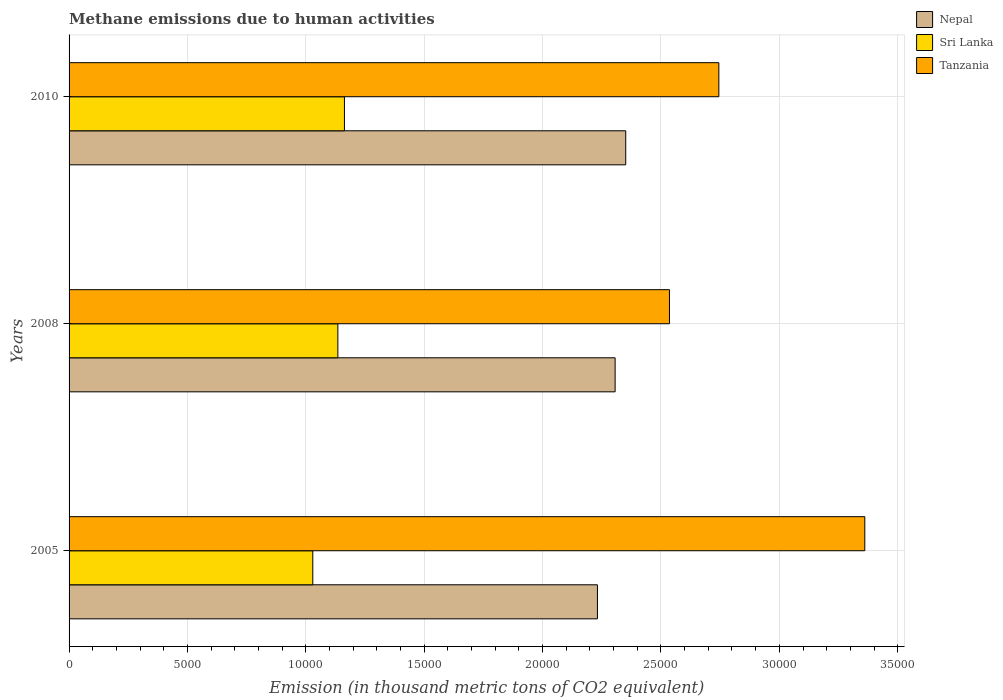How many different coloured bars are there?
Ensure brevity in your answer.  3. Are the number of bars per tick equal to the number of legend labels?
Make the answer very short. Yes. How many bars are there on the 1st tick from the top?
Offer a very short reply. 3. What is the label of the 3rd group of bars from the top?
Your response must be concise. 2005. What is the amount of methane emitted in Tanzania in 2005?
Ensure brevity in your answer.  3.36e+04. Across all years, what is the maximum amount of methane emitted in Sri Lanka?
Make the answer very short. 1.16e+04. Across all years, what is the minimum amount of methane emitted in Sri Lanka?
Make the answer very short. 1.03e+04. In which year was the amount of methane emitted in Sri Lanka maximum?
Your response must be concise. 2010. In which year was the amount of methane emitted in Nepal minimum?
Offer a terse response. 2005. What is the total amount of methane emitted in Nepal in the graph?
Offer a terse response. 6.89e+04. What is the difference between the amount of methane emitted in Sri Lanka in 2008 and that in 2010?
Your response must be concise. -277.7. What is the difference between the amount of methane emitted in Sri Lanka in 2010 and the amount of methane emitted in Nepal in 2005?
Offer a terse response. -1.07e+04. What is the average amount of methane emitted in Tanzania per year?
Provide a succinct answer. 2.88e+04. In the year 2008, what is the difference between the amount of methane emitted in Sri Lanka and amount of methane emitted in Nepal?
Offer a very short reply. -1.17e+04. In how many years, is the amount of methane emitted in Tanzania greater than 34000 thousand metric tons?
Your answer should be compact. 0. What is the ratio of the amount of methane emitted in Sri Lanka in 2005 to that in 2010?
Offer a terse response. 0.89. Is the amount of methane emitted in Nepal in 2005 less than that in 2010?
Your answer should be compact. Yes. Is the difference between the amount of methane emitted in Sri Lanka in 2005 and 2008 greater than the difference between the amount of methane emitted in Nepal in 2005 and 2008?
Your response must be concise. No. What is the difference between the highest and the second highest amount of methane emitted in Sri Lanka?
Your answer should be very brief. 277.7. What is the difference between the highest and the lowest amount of methane emitted in Nepal?
Ensure brevity in your answer.  1195.2. What does the 2nd bar from the top in 2010 represents?
Offer a very short reply. Sri Lanka. What does the 3rd bar from the bottom in 2005 represents?
Offer a very short reply. Tanzania. Does the graph contain any zero values?
Offer a terse response. No. Where does the legend appear in the graph?
Your response must be concise. Top right. How many legend labels are there?
Provide a short and direct response. 3. What is the title of the graph?
Offer a very short reply. Methane emissions due to human activities. Does "Turkey" appear as one of the legend labels in the graph?
Offer a terse response. No. What is the label or title of the X-axis?
Your answer should be very brief. Emission (in thousand metric tons of CO2 equivalent). What is the label or title of the Y-axis?
Keep it short and to the point. Years. What is the Emission (in thousand metric tons of CO2 equivalent) of Nepal in 2005?
Your answer should be very brief. 2.23e+04. What is the Emission (in thousand metric tons of CO2 equivalent) of Sri Lanka in 2005?
Offer a terse response. 1.03e+04. What is the Emission (in thousand metric tons of CO2 equivalent) in Tanzania in 2005?
Provide a succinct answer. 3.36e+04. What is the Emission (in thousand metric tons of CO2 equivalent) in Nepal in 2008?
Provide a short and direct response. 2.31e+04. What is the Emission (in thousand metric tons of CO2 equivalent) of Sri Lanka in 2008?
Your response must be concise. 1.14e+04. What is the Emission (in thousand metric tons of CO2 equivalent) in Tanzania in 2008?
Keep it short and to the point. 2.54e+04. What is the Emission (in thousand metric tons of CO2 equivalent) of Nepal in 2010?
Offer a very short reply. 2.35e+04. What is the Emission (in thousand metric tons of CO2 equivalent) in Sri Lanka in 2010?
Ensure brevity in your answer.  1.16e+04. What is the Emission (in thousand metric tons of CO2 equivalent) in Tanzania in 2010?
Keep it short and to the point. 2.74e+04. Across all years, what is the maximum Emission (in thousand metric tons of CO2 equivalent) of Nepal?
Offer a terse response. 2.35e+04. Across all years, what is the maximum Emission (in thousand metric tons of CO2 equivalent) in Sri Lanka?
Offer a very short reply. 1.16e+04. Across all years, what is the maximum Emission (in thousand metric tons of CO2 equivalent) of Tanzania?
Offer a very short reply. 3.36e+04. Across all years, what is the minimum Emission (in thousand metric tons of CO2 equivalent) of Nepal?
Ensure brevity in your answer.  2.23e+04. Across all years, what is the minimum Emission (in thousand metric tons of CO2 equivalent) in Sri Lanka?
Ensure brevity in your answer.  1.03e+04. Across all years, what is the minimum Emission (in thousand metric tons of CO2 equivalent) of Tanzania?
Make the answer very short. 2.54e+04. What is the total Emission (in thousand metric tons of CO2 equivalent) in Nepal in the graph?
Keep it short and to the point. 6.89e+04. What is the total Emission (in thousand metric tons of CO2 equivalent) in Sri Lanka in the graph?
Make the answer very short. 3.33e+04. What is the total Emission (in thousand metric tons of CO2 equivalent) in Tanzania in the graph?
Keep it short and to the point. 8.64e+04. What is the difference between the Emission (in thousand metric tons of CO2 equivalent) of Nepal in 2005 and that in 2008?
Your answer should be compact. -747. What is the difference between the Emission (in thousand metric tons of CO2 equivalent) of Sri Lanka in 2005 and that in 2008?
Ensure brevity in your answer.  -1058.7. What is the difference between the Emission (in thousand metric tons of CO2 equivalent) in Tanzania in 2005 and that in 2008?
Offer a terse response. 8250.3. What is the difference between the Emission (in thousand metric tons of CO2 equivalent) of Nepal in 2005 and that in 2010?
Your response must be concise. -1195.2. What is the difference between the Emission (in thousand metric tons of CO2 equivalent) in Sri Lanka in 2005 and that in 2010?
Offer a terse response. -1336.4. What is the difference between the Emission (in thousand metric tons of CO2 equivalent) in Tanzania in 2005 and that in 2010?
Offer a terse response. 6164.8. What is the difference between the Emission (in thousand metric tons of CO2 equivalent) of Nepal in 2008 and that in 2010?
Keep it short and to the point. -448.2. What is the difference between the Emission (in thousand metric tons of CO2 equivalent) of Sri Lanka in 2008 and that in 2010?
Provide a succinct answer. -277.7. What is the difference between the Emission (in thousand metric tons of CO2 equivalent) of Tanzania in 2008 and that in 2010?
Your answer should be very brief. -2085.5. What is the difference between the Emission (in thousand metric tons of CO2 equivalent) of Nepal in 2005 and the Emission (in thousand metric tons of CO2 equivalent) of Sri Lanka in 2008?
Provide a succinct answer. 1.10e+04. What is the difference between the Emission (in thousand metric tons of CO2 equivalent) in Nepal in 2005 and the Emission (in thousand metric tons of CO2 equivalent) in Tanzania in 2008?
Provide a short and direct response. -3042.7. What is the difference between the Emission (in thousand metric tons of CO2 equivalent) in Sri Lanka in 2005 and the Emission (in thousand metric tons of CO2 equivalent) in Tanzania in 2008?
Provide a succinct answer. -1.51e+04. What is the difference between the Emission (in thousand metric tons of CO2 equivalent) in Nepal in 2005 and the Emission (in thousand metric tons of CO2 equivalent) in Sri Lanka in 2010?
Your response must be concise. 1.07e+04. What is the difference between the Emission (in thousand metric tons of CO2 equivalent) in Nepal in 2005 and the Emission (in thousand metric tons of CO2 equivalent) in Tanzania in 2010?
Your answer should be compact. -5128.2. What is the difference between the Emission (in thousand metric tons of CO2 equivalent) in Sri Lanka in 2005 and the Emission (in thousand metric tons of CO2 equivalent) in Tanzania in 2010?
Ensure brevity in your answer.  -1.72e+04. What is the difference between the Emission (in thousand metric tons of CO2 equivalent) of Nepal in 2008 and the Emission (in thousand metric tons of CO2 equivalent) of Sri Lanka in 2010?
Offer a terse response. 1.14e+04. What is the difference between the Emission (in thousand metric tons of CO2 equivalent) in Nepal in 2008 and the Emission (in thousand metric tons of CO2 equivalent) in Tanzania in 2010?
Your answer should be compact. -4381.2. What is the difference between the Emission (in thousand metric tons of CO2 equivalent) in Sri Lanka in 2008 and the Emission (in thousand metric tons of CO2 equivalent) in Tanzania in 2010?
Your answer should be compact. -1.61e+04. What is the average Emission (in thousand metric tons of CO2 equivalent) of Nepal per year?
Your response must be concise. 2.30e+04. What is the average Emission (in thousand metric tons of CO2 equivalent) in Sri Lanka per year?
Offer a terse response. 1.11e+04. What is the average Emission (in thousand metric tons of CO2 equivalent) in Tanzania per year?
Provide a short and direct response. 2.88e+04. In the year 2005, what is the difference between the Emission (in thousand metric tons of CO2 equivalent) in Nepal and Emission (in thousand metric tons of CO2 equivalent) in Sri Lanka?
Ensure brevity in your answer.  1.20e+04. In the year 2005, what is the difference between the Emission (in thousand metric tons of CO2 equivalent) in Nepal and Emission (in thousand metric tons of CO2 equivalent) in Tanzania?
Your answer should be very brief. -1.13e+04. In the year 2005, what is the difference between the Emission (in thousand metric tons of CO2 equivalent) of Sri Lanka and Emission (in thousand metric tons of CO2 equivalent) of Tanzania?
Make the answer very short. -2.33e+04. In the year 2008, what is the difference between the Emission (in thousand metric tons of CO2 equivalent) of Nepal and Emission (in thousand metric tons of CO2 equivalent) of Sri Lanka?
Provide a succinct answer. 1.17e+04. In the year 2008, what is the difference between the Emission (in thousand metric tons of CO2 equivalent) in Nepal and Emission (in thousand metric tons of CO2 equivalent) in Tanzania?
Your response must be concise. -2295.7. In the year 2008, what is the difference between the Emission (in thousand metric tons of CO2 equivalent) in Sri Lanka and Emission (in thousand metric tons of CO2 equivalent) in Tanzania?
Provide a succinct answer. -1.40e+04. In the year 2010, what is the difference between the Emission (in thousand metric tons of CO2 equivalent) in Nepal and Emission (in thousand metric tons of CO2 equivalent) in Sri Lanka?
Your response must be concise. 1.19e+04. In the year 2010, what is the difference between the Emission (in thousand metric tons of CO2 equivalent) of Nepal and Emission (in thousand metric tons of CO2 equivalent) of Tanzania?
Ensure brevity in your answer.  -3933. In the year 2010, what is the difference between the Emission (in thousand metric tons of CO2 equivalent) of Sri Lanka and Emission (in thousand metric tons of CO2 equivalent) of Tanzania?
Ensure brevity in your answer.  -1.58e+04. What is the ratio of the Emission (in thousand metric tons of CO2 equivalent) of Nepal in 2005 to that in 2008?
Make the answer very short. 0.97. What is the ratio of the Emission (in thousand metric tons of CO2 equivalent) of Sri Lanka in 2005 to that in 2008?
Give a very brief answer. 0.91. What is the ratio of the Emission (in thousand metric tons of CO2 equivalent) in Tanzania in 2005 to that in 2008?
Your answer should be very brief. 1.33. What is the ratio of the Emission (in thousand metric tons of CO2 equivalent) in Nepal in 2005 to that in 2010?
Offer a terse response. 0.95. What is the ratio of the Emission (in thousand metric tons of CO2 equivalent) of Sri Lanka in 2005 to that in 2010?
Offer a very short reply. 0.89. What is the ratio of the Emission (in thousand metric tons of CO2 equivalent) in Tanzania in 2005 to that in 2010?
Your response must be concise. 1.22. What is the ratio of the Emission (in thousand metric tons of CO2 equivalent) of Nepal in 2008 to that in 2010?
Ensure brevity in your answer.  0.98. What is the ratio of the Emission (in thousand metric tons of CO2 equivalent) of Sri Lanka in 2008 to that in 2010?
Your response must be concise. 0.98. What is the ratio of the Emission (in thousand metric tons of CO2 equivalent) of Tanzania in 2008 to that in 2010?
Provide a short and direct response. 0.92. What is the difference between the highest and the second highest Emission (in thousand metric tons of CO2 equivalent) of Nepal?
Make the answer very short. 448.2. What is the difference between the highest and the second highest Emission (in thousand metric tons of CO2 equivalent) in Sri Lanka?
Provide a short and direct response. 277.7. What is the difference between the highest and the second highest Emission (in thousand metric tons of CO2 equivalent) in Tanzania?
Keep it short and to the point. 6164.8. What is the difference between the highest and the lowest Emission (in thousand metric tons of CO2 equivalent) in Nepal?
Give a very brief answer. 1195.2. What is the difference between the highest and the lowest Emission (in thousand metric tons of CO2 equivalent) of Sri Lanka?
Offer a terse response. 1336.4. What is the difference between the highest and the lowest Emission (in thousand metric tons of CO2 equivalent) of Tanzania?
Make the answer very short. 8250.3. 